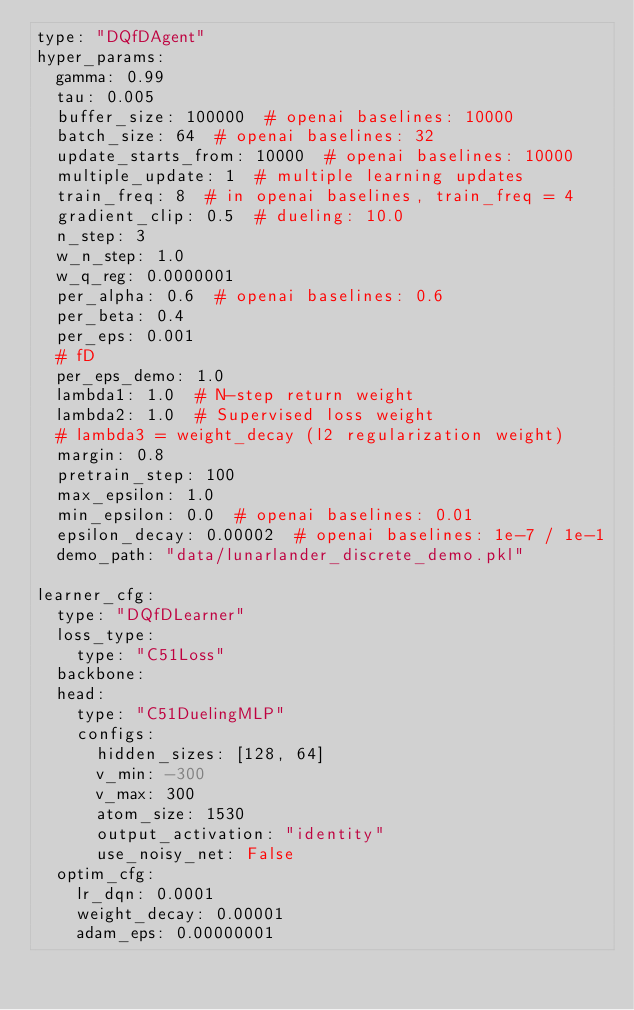Convert code to text. <code><loc_0><loc_0><loc_500><loc_500><_YAML_>type: "DQfDAgent"
hyper_params:
  gamma: 0.99
  tau: 0.005
  buffer_size: 100000  # openai baselines: 10000
  batch_size: 64  # openai baselines: 32
  update_starts_from: 10000  # openai baselines: 10000
  multiple_update: 1  # multiple learning updates
  train_freq: 8  # in openai baselines, train_freq = 4
  gradient_clip: 0.5  # dueling: 10.0
  n_step: 3
  w_n_step: 1.0
  w_q_reg: 0.0000001
  per_alpha: 0.6  # openai baselines: 0.6
  per_beta: 0.4
  per_eps: 0.001
  # fD
  per_eps_demo: 1.0
  lambda1: 1.0  # N-step return weight
  lambda2: 1.0  # Supervised loss weight
  # lambda3 = weight_decay (l2 regularization weight)
  margin: 0.8
  pretrain_step: 100
  max_epsilon: 1.0
  min_epsilon: 0.0  # openai baselines: 0.01
  epsilon_decay: 0.00002  # openai baselines: 1e-7 / 1e-1
  demo_path: "data/lunarlander_discrete_demo.pkl"

learner_cfg:
  type: "DQfDLearner"
  loss_type:
    type: "C51Loss"
  backbone:
  head:
    type: "C51DuelingMLP"
    configs: 
      hidden_sizes: [128, 64]
      v_min: -300
      v_max: 300
      atom_size: 1530
      output_activation: "identity"
      use_noisy_net: False
  optim_cfg:
    lr_dqn: 0.0001
    weight_decay: 0.00001
    adam_eps: 0.00000001
</code> 